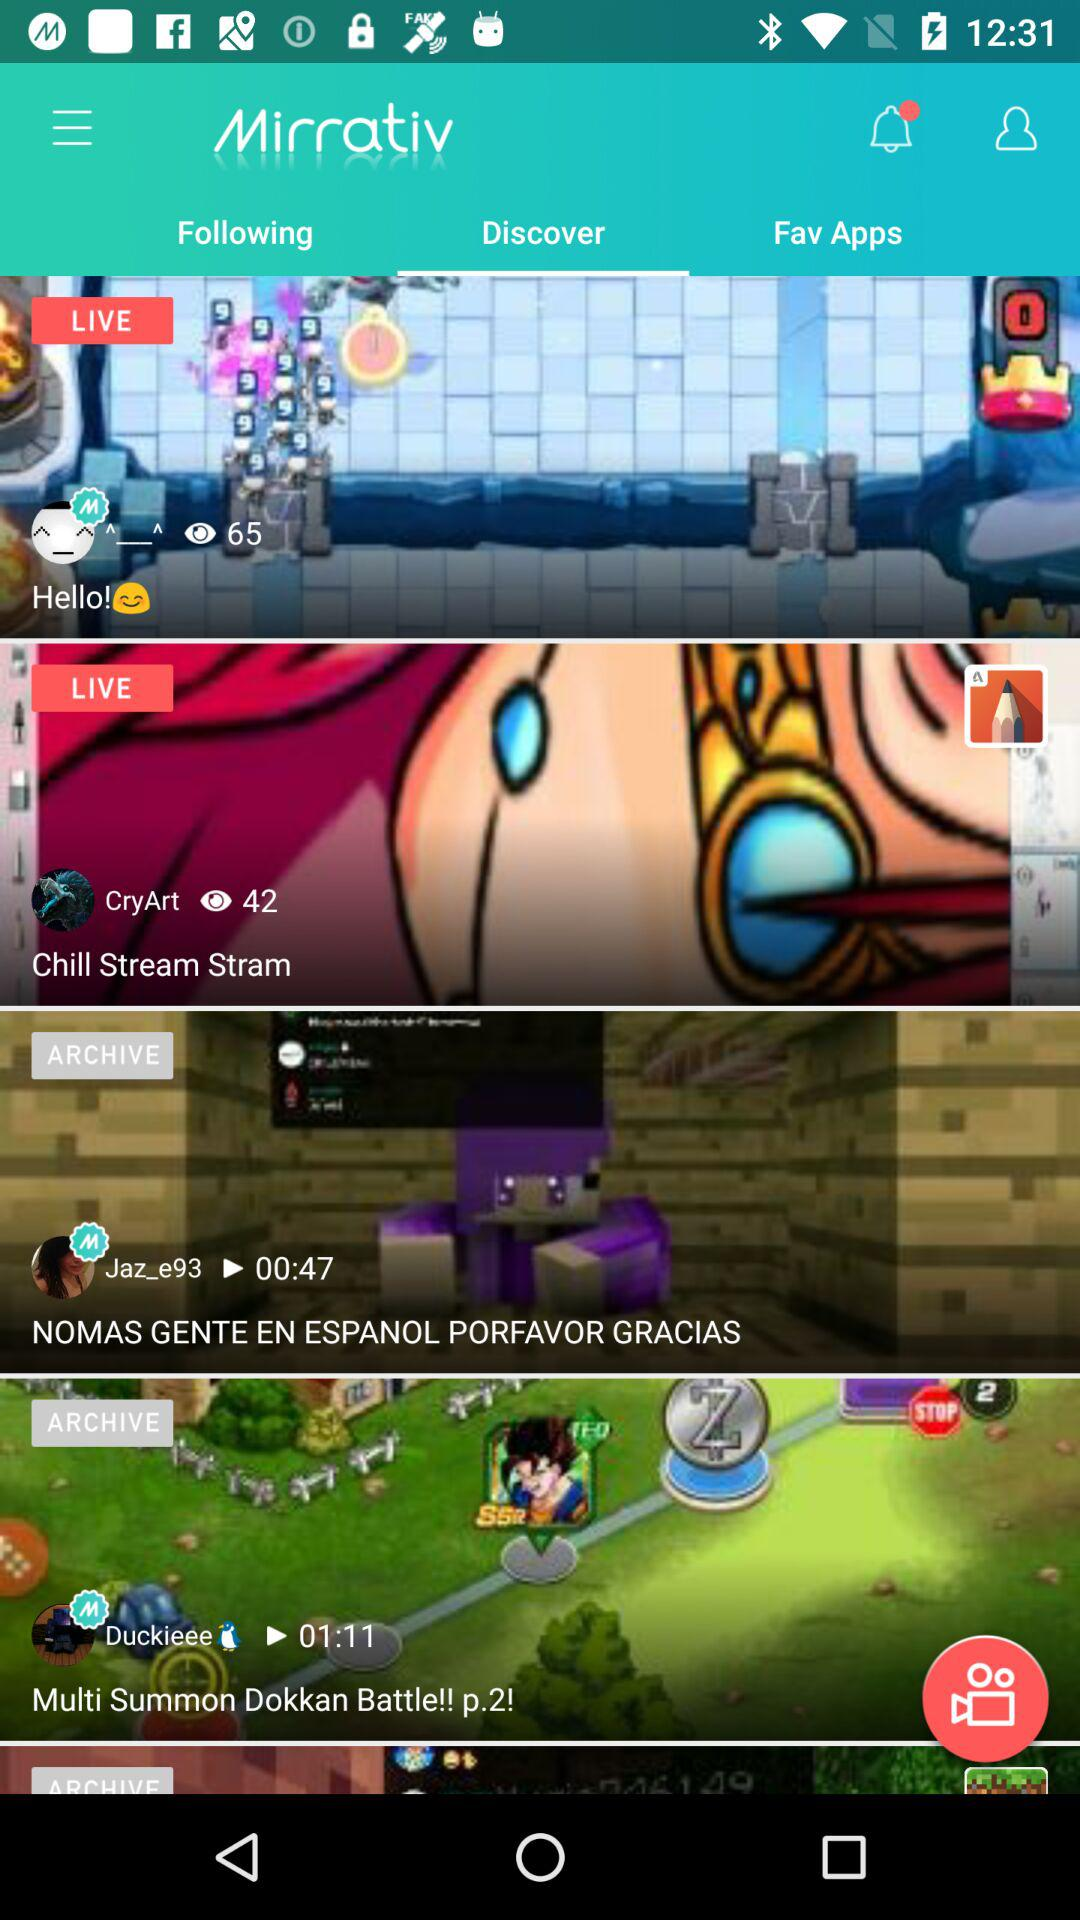How many of the items are live streams?
Answer the question using a single word or phrase. 2 